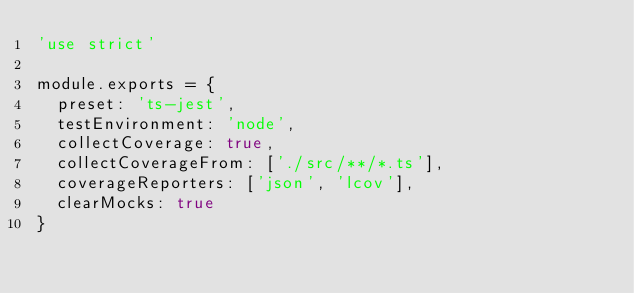<code> <loc_0><loc_0><loc_500><loc_500><_JavaScript_>'use strict'

module.exports = {
  preset: 'ts-jest',
  testEnvironment: 'node',
  collectCoverage: true,
  collectCoverageFrom: ['./src/**/*.ts'],
  coverageReporters: ['json', 'lcov'],
  clearMocks: true
}
</code> 